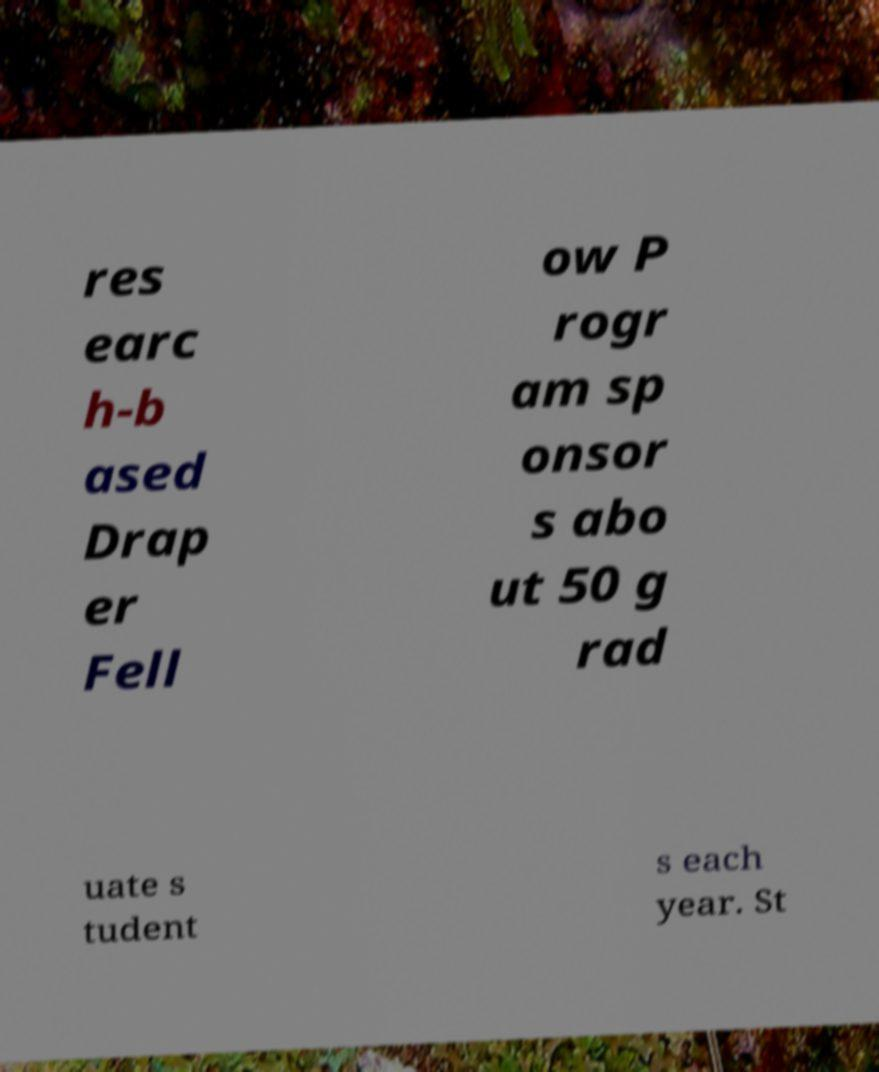I need the written content from this picture converted into text. Can you do that? res earc h-b ased Drap er Fell ow P rogr am sp onsor s abo ut 50 g rad uate s tudent s each year. St 